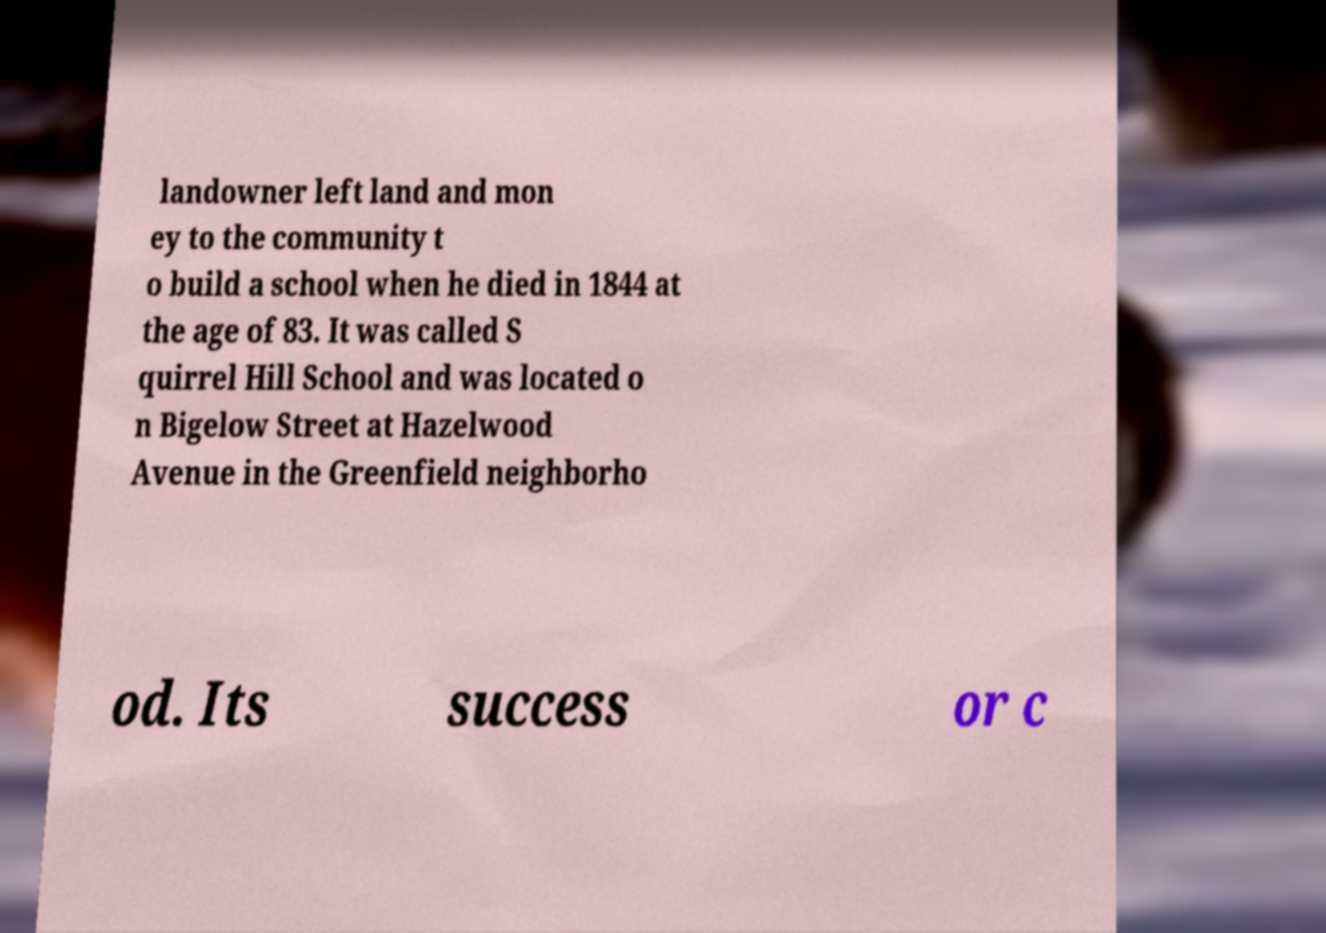What messages or text are displayed in this image? I need them in a readable, typed format. landowner left land and mon ey to the community t o build a school when he died in 1844 at the age of 83. It was called S quirrel Hill School and was located o n Bigelow Street at Hazelwood Avenue in the Greenfield neighborho od. Its success or c 